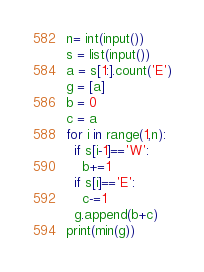<code> <loc_0><loc_0><loc_500><loc_500><_Python_>n= int(input())
s = list(input())
a = s[1:].count('E')
g = [a]
b = 0
c = a
for i in range(1,n):
  if s[i-1]=='W':
    b+=1
  if s[i]=='E':
    c-=1
  g.append(b+c)
print(min(g))</code> 